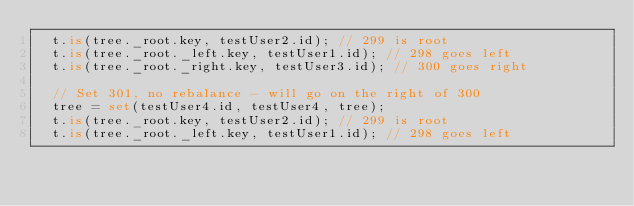<code> <loc_0><loc_0><loc_500><loc_500><_TypeScript_>  t.is(tree._root.key, testUser2.id); // 299 is root
  t.is(tree._root._left.key, testUser1.id); // 298 goes left
  t.is(tree._root._right.key, testUser3.id); // 300 goes right

  // Set 301, no rebalance - will go on the right of 300
  tree = set(testUser4.id, testUser4, tree);
  t.is(tree._root.key, testUser2.id); // 299 is root
  t.is(tree._root._left.key, testUser1.id); // 298 goes left</code> 